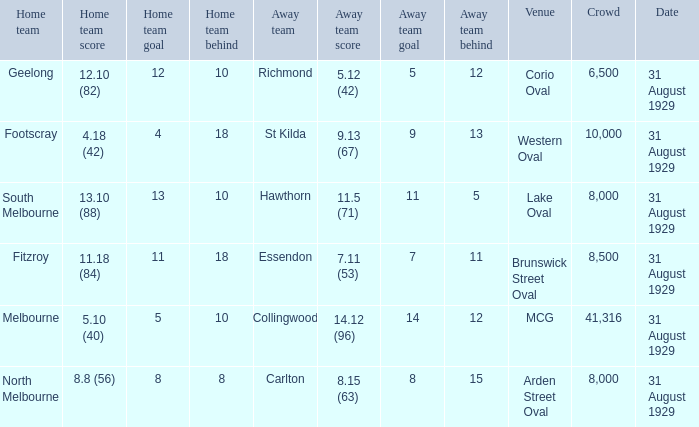What is the score of the away team when the crowd was larger than 8,000? 9.13 (67), 7.11 (53), 14.12 (96). 